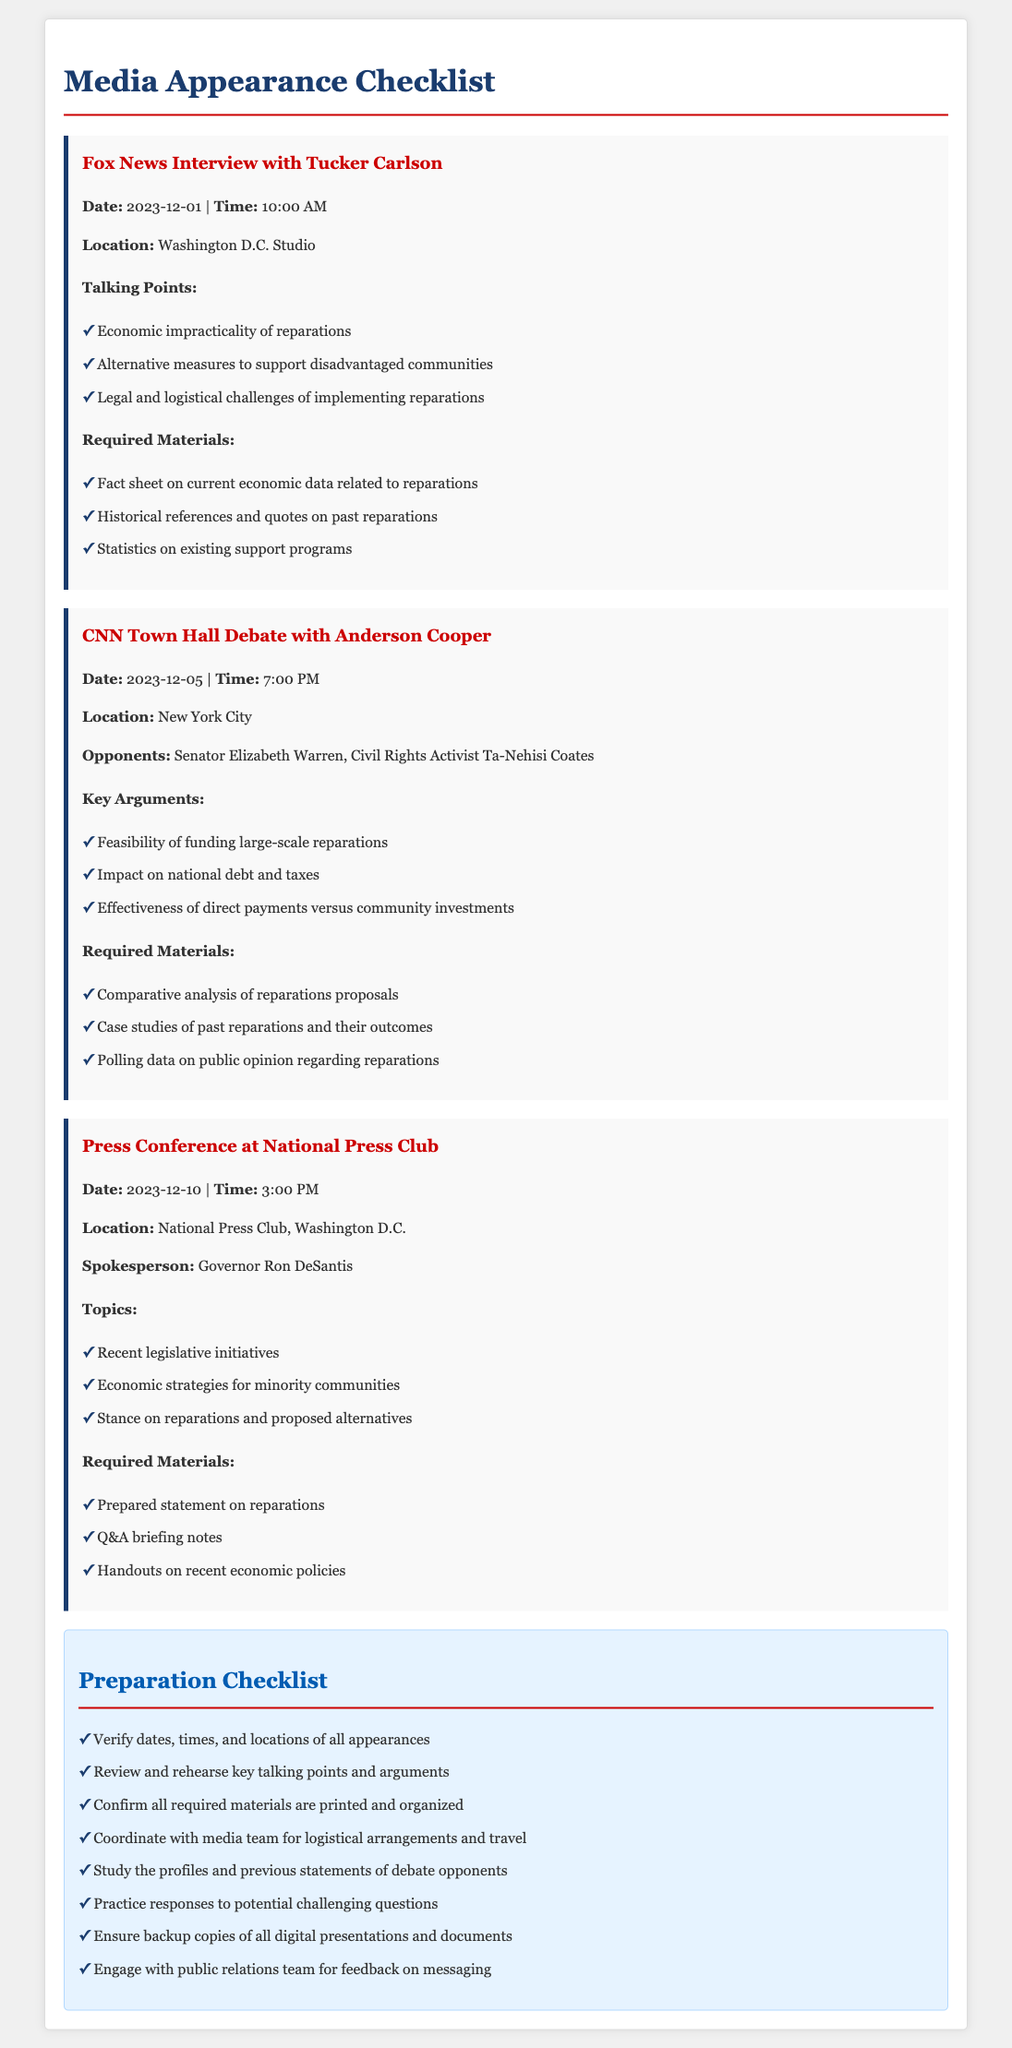What is the date of the Fox News interview? The Fox News interview is scheduled for December 1, 2023.
Answer: December 1, 2023 Who is the spokesperson for the Press Conference? The spokesperson for the Press Conference is Governor Ron DeSantis.
Answer: Governor Ron DeSantis What are the key arguments for the CNN Town Hall Debate? The key arguments include feasibility of funding, impact on national debt, and effectiveness of payments.
Answer: Feasibility of funding, impact on national debt, effectiveness of direct payments What is required for the Fox News interview? Required materials for the Fox News interview include fact sheets, historical references, and statistics.
Answer: Fact sheet on current economic data, historical references, statistics on existing support programs What time is the Press Conference scheduled for? The Press Conference is scheduled for 3:00 PM.
Answer: 3:00 PM What topic is addressed at the Press Conference? The topics addressed include recent legislative initiatives and economic strategies.
Answer: Recent legislative initiatives, economic strategies for minority communities, stance on reparations What is one of the required materials for the CNN Town Hall Debate? One of the required materials is polling data on public opinion regarding reparations.
Answer: Polling data on public opinion regarding reparations How many appearances are listed in the document? There are three appearances listed in the document.
Answer: Three What should be verified according to the Preparation Checklist? The checklist states to verify dates, times, and locations of all appearances.
Answer: Dates, times, and locations of all appearances 